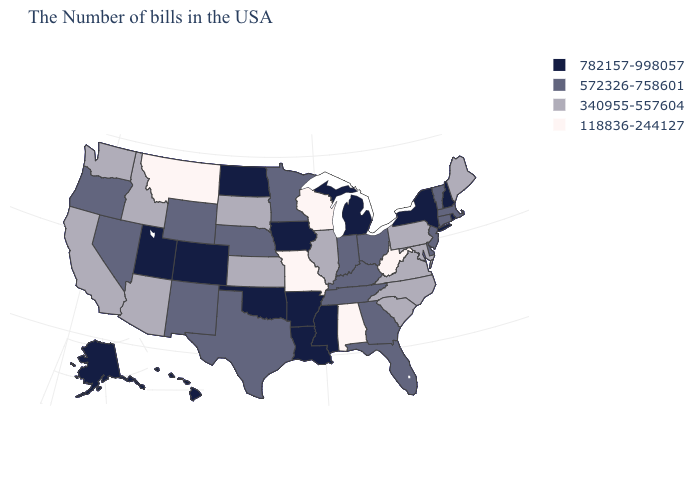Name the states that have a value in the range 340955-557604?
Concise answer only. Maine, Maryland, Pennsylvania, Virginia, North Carolina, South Carolina, Illinois, Kansas, South Dakota, Arizona, Idaho, California, Washington. What is the value of Arkansas?
Concise answer only. 782157-998057. Does Maryland have the same value as Connecticut?
Concise answer only. No. Among the states that border Texas , which have the highest value?
Answer briefly. Louisiana, Arkansas, Oklahoma. Name the states that have a value in the range 118836-244127?
Concise answer only. West Virginia, Alabama, Wisconsin, Missouri, Montana. Does Missouri have the lowest value in the MidWest?
Concise answer only. Yes. What is the lowest value in the Northeast?
Be succinct. 340955-557604. Which states have the lowest value in the Northeast?
Answer briefly. Maine, Pennsylvania. What is the value of Alaska?
Concise answer only. 782157-998057. Which states hav the highest value in the Northeast?
Quick response, please. Rhode Island, New Hampshire, New York. What is the lowest value in states that border Massachusetts?
Concise answer only. 572326-758601. Name the states that have a value in the range 118836-244127?
Write a very short answer. West Virginia, Alabama, Wisconsin, Missouri, Montana. Does Michigan have a lower value than Washington?
Short answer required. No. Does New Jersey have the lowest value in the USA?
Concise answer only. No. 